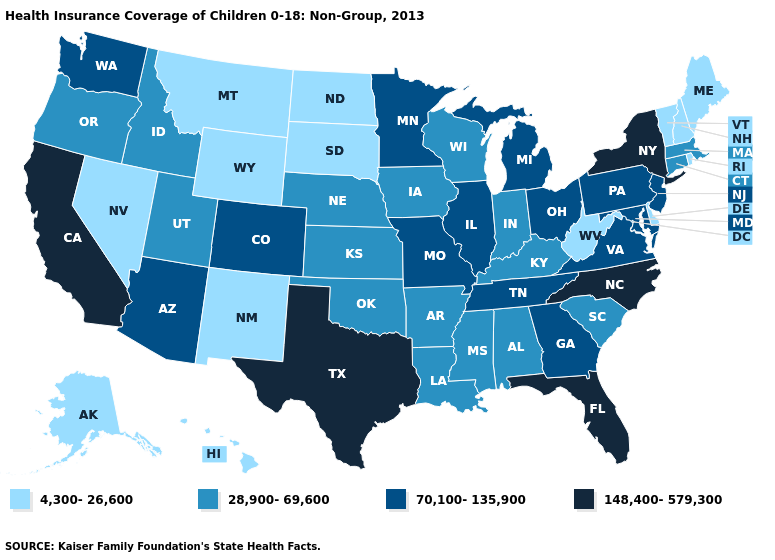Which states have the lowest value in the Northeast?
Write a very short answer. Maine, New Hampshire, Rhode Island, Vermont. Does Alaska have the lowest value in the West?
Concise answer only. Yes. Name the states that have a value in the range 148,400-579,300?
Quick response, please. California, Florida, New York, North Carolina, Texas. Which states have the lowest value in the USA?
Quick response, please. Alaska, Delaware, Hawaii, Maine, Montana, Nevada, New Hampshire, New Mexico, North Dakota, Rhode Island, South Dakota, Vermont, West Virginia, Wyoming. Which states hav the highest value in the MidWest?
Quick response, please. Illinois, Michigan, Minnesota, Missouri, Ohio. Name the states that have a value in the range 70,100-135,900?
Keep it brief. Arizona, Colorado, Georgia, Illinois, Maryland, Michigan, Minnesota, Missouri, New Jersey, Ohio, Pennsylvania, Tennessee, Virginia, Washington. Does Wisconsin have the highest value in the USA?
Quick response, please. No. Among the states that border New York , which have the highest value?
Concise answer only. New Jersey, Pennsylvania. Name the states that have a value in the range 28,900-69,600?
Quick response, please. Alabama, Arkansas, Connecticut, Idaho, Indiana, Iowa, Kansas, Kentucky, Louisiana, Massachusetts, Mississippi, Nebraska, Oklahoma, Oregon, South Carolina, Utah, Wisconsin. What is the value of Massachusetts?
Give a very brief answer. 28,900-69,600. Does North Dakota have the lowest value in the MidWest?
Keep it brief. Yes. Name the states that have a value in the range 70,100-135,900?
Short answer required. Arizona, Colorado, Georgia, Illinois, Maryland, Michigan, Minnesota, Missouri, New Jersey, Ohio, Pennsylvania, Tennessee, Virginia, Washington. Does Tennessee have the lowest value in the South?
Be succinct. No. Among the states that border Delaware , which have the highest value?
Write a very short answer. Maryland, New Jersey, Pennsylvania. Does Iowa have the same value as Nebraska?
Be succinct. Yes. 